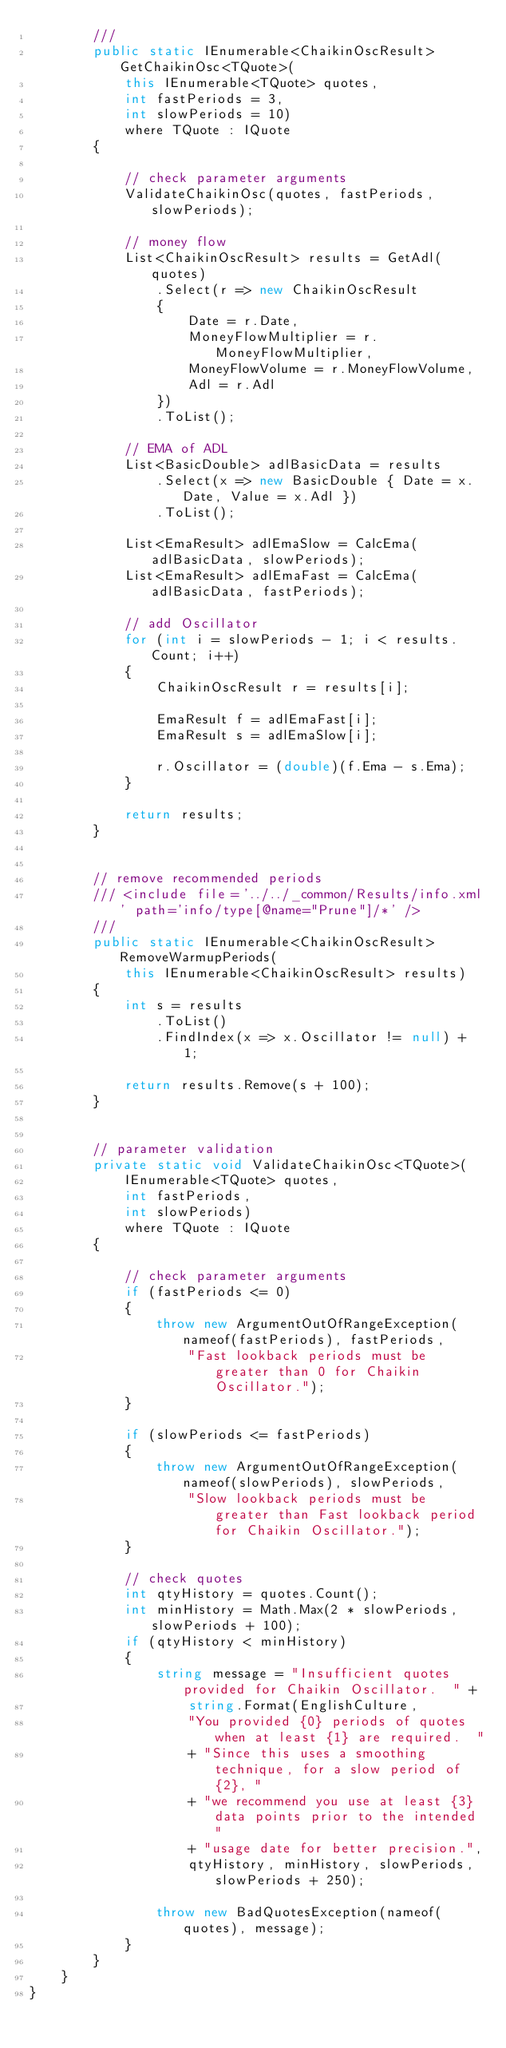Convert code to text. <code><loc_0><loc_0><loc_500><loc_500><_C#_>        /// 
        public static IEnumerable<ChaikinOscResult> GetChaikinOsc<TQuote>(
            this IEnumerable<TQuote> quotes,
            int fastPeriods = 3,
            int slowPeriods = 10)
            where TQuote : IQuote
        {

            // check parameter arguments
            ValidateChaikinOsc(quotes, fastPeriods, slowPeriods);

            // money flow
            List<ChaikinOscResult> results = GetAdl(quotes)
                .Select(r => new ChaikinOscResult
                {
                    Date = r.Date,
                    MoneyFlowMultiplier = r.MoneyFlowMultiplier,
                    MoneyFlowVolume = r.MoneyFlowVolume,
                    Adl = r.Adl
                })
                .ToList();

            // EMA of ADL
            List<BasicDouble> adlBasicData = results
                .Select(x => new BasicDouble { Date = x.Date, Value = x.Adl })
                .ToList();

            List<EmaResult> adlEmaSlow = CalcEma(adlBasicData, slowPeriods);
            List<EmaResult> adlEmaFast = CalcEma(adlBasicData, fastPeriods);

            // add Oscillator
            for (int i = slowPeriods - 1; i < results.Count; i++)
            {
                ChaikinOscResult r = results[i];

                EmaResult f = adlEmaFast[i];
                EmaResult s = adlEmaSlow[i];

                r.Oscillator = (double)(f.Ema - s.Ema);
            }

            return results;
        }


        // remove recommended periods
        /// <include file='../../_common/Results/info.xml' path='info/type[@name="Prune"]/*' />
        ///
        public static IEnumerable<ChaikinOscResult> RemoveWarmupPeriods(
            this IEnumerable<ChaikinOscResult> results)
        {
            int s = results
                .ToList()
                .FindIndex(x => x.Oscillator != null) + 1;

            return results.Remove(s + 100);
        }


        // parameter validation
        private static void ValidateChaikinOsc<TQuote>(
            IEnumerable<TQuote> quotes,
            int fastPeriods,
            int slowPeriods)
            where TQuote : IQuote
        {

            // check parameter arguments
            if (fastPeriods <= 0)
            {
                throw new ArgumentOutOfRangeException(nameof(fastPeriods), fastPeriods,
                    "Fast lookback periods must be greater than 0 for Chaikin Oscillator.");
            }

            if (slowPeriods <= fastPeriods)
            {
                throw new ArgumentOutOfRangeException(nameof(slowPeriods), slowPeriods,
                    "Slow lookback periods must be greater than Fast lookback period for Chaikin Oscillator.");
            }

            // check quotes
            int qtyHistory = quotes.Count();
            int minHistory = Math.Max(2 * slowPeriods, slowPeriods + 100);
            if (qtyHistory < minHistory)
            {
                string message = "Insufficient quotes provided for Chaikin Oscillator.  " +
                    string.Format(EnglishCulture,
                    "You provided {0} periods of quotes when at least {1} are required.  "
                    + "Since this uses a smoothing technique, for a slow period of {2}, "
                    + "we recommend you use at least {3} data points prior to the intended "
                    + "usage date for better precision.",
                    qtyHistory, minHistory, slowPeriods, slowPeriods + 250);

                throw new BadQuotesException(nameof(quotes), message);
            }
        }
    }
}
</code> 